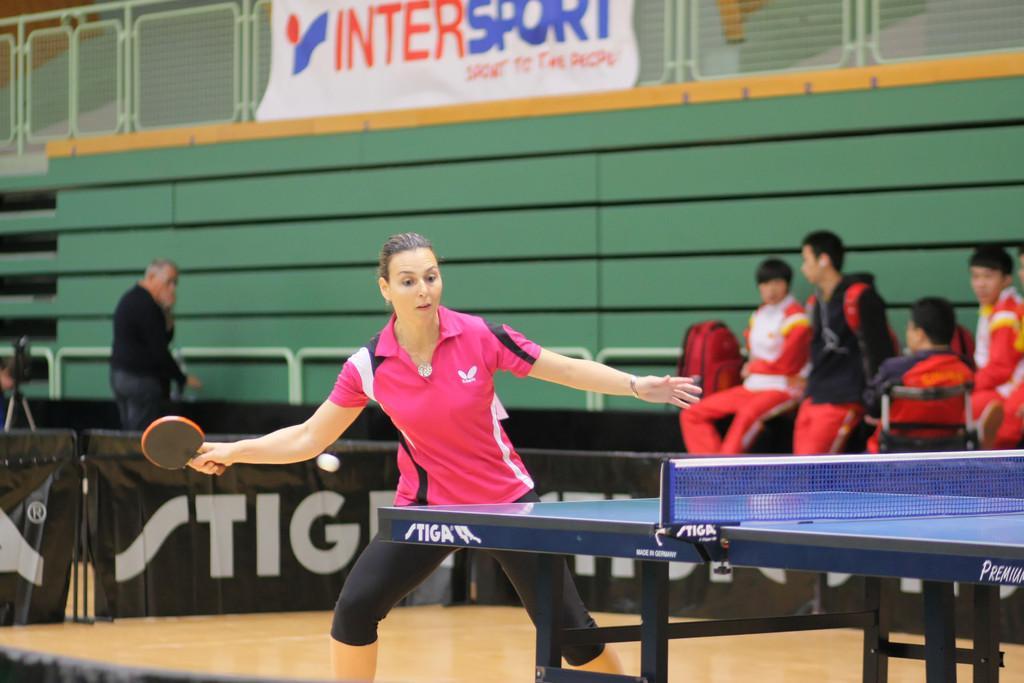Describe this image in one or two sentences. There is a lady holding a table tennis bat in the foreground area of the image, there is a tennis table on the right side. There are people, poster and boundaries in the background. 